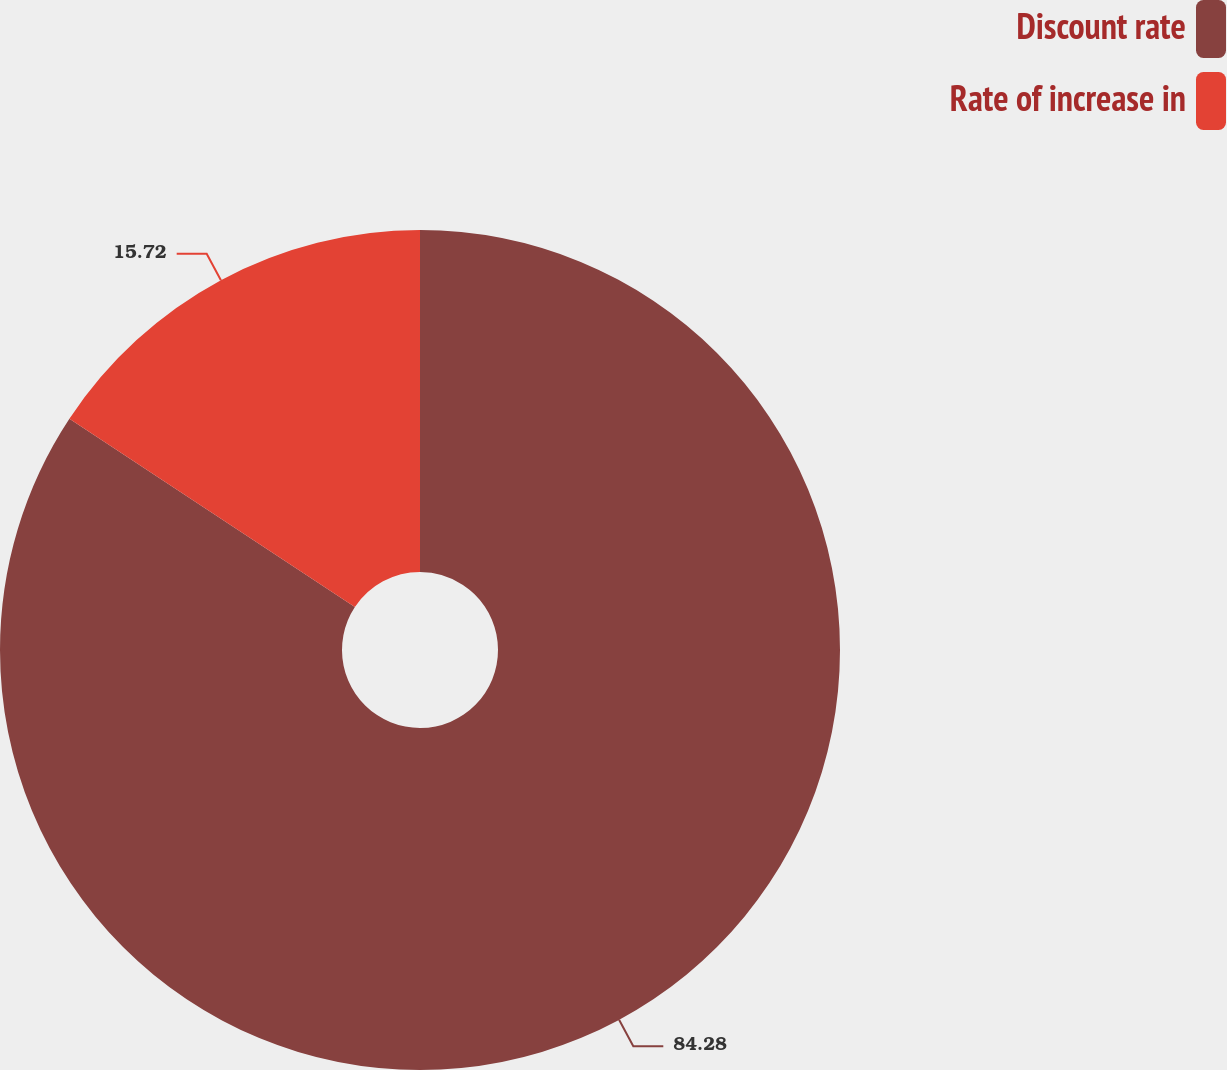<chart> <loc_0><loc_0><loc_500><loc_500><pie_chart><fcel>Discount rate<fcel>Rate of increase in<nl><fcel>84.28%<fcel>15.72%<nl></chart> 